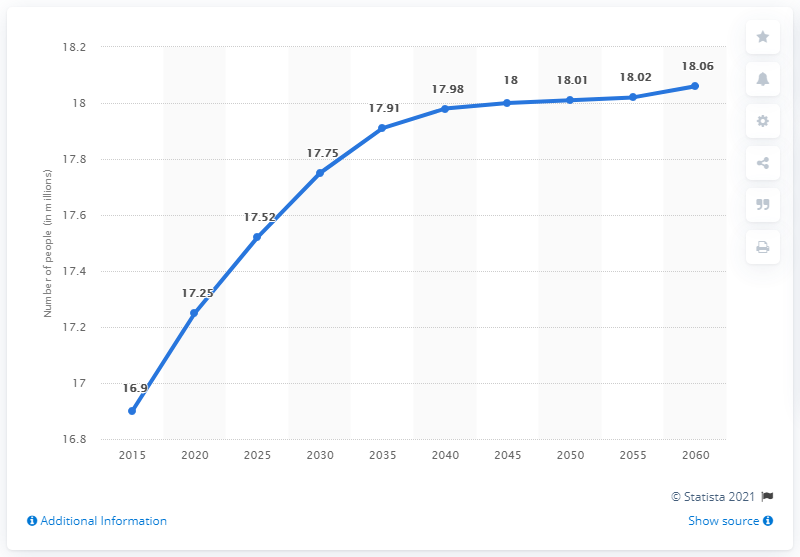List a handful of essential elements in this visual. It is predicted that the number of people living in the Netherlands will be 16.9 million between 2015 and 2060. In 2015, the population of the Netherlands was 16.9 million. 